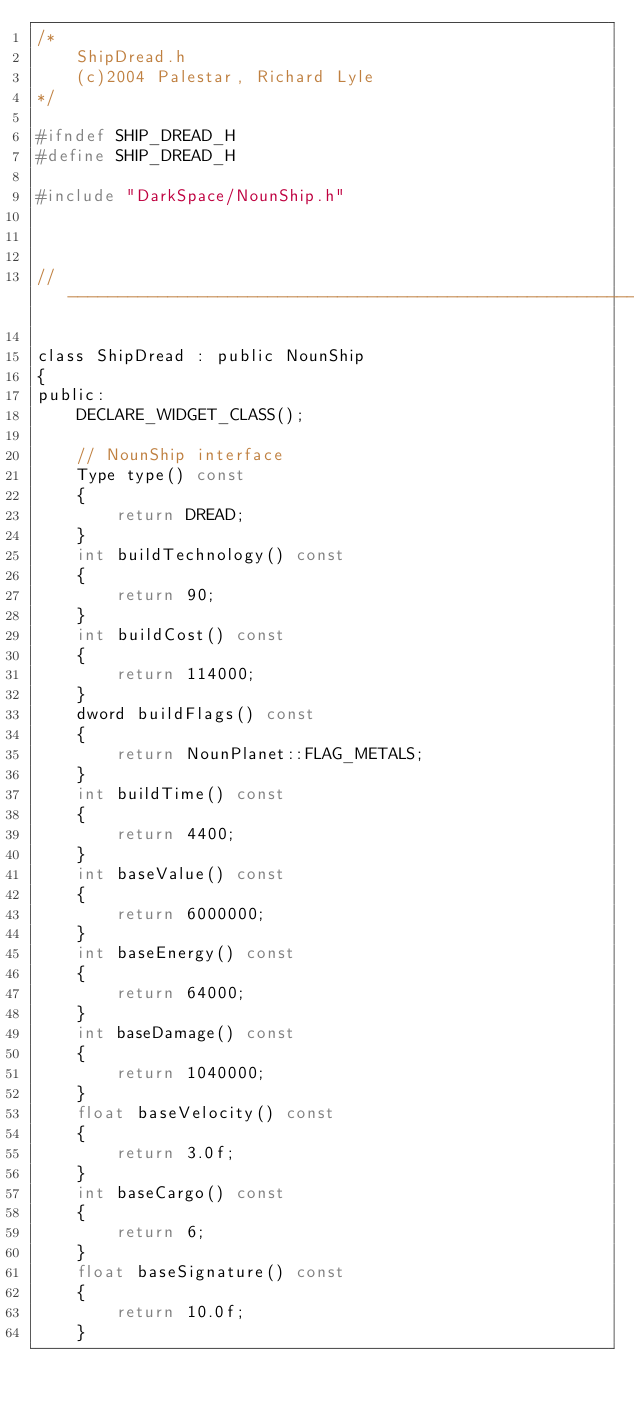Convert code to text. <code><loc_0><loc_0><loc_500><loc_500><_C_>/*
	ShipDread.h
	(c)2004 Palestar, Richard Lyle
*/

#ifndef SHIP_DREAD_H
#define SHIP_DREAD_H

#include "DarkSpace/NounShip.h"



//----------------------------------------------------------------------------

class ShipDread : public NounShip
{
public:
	DECLARE_WIDGET_CLASS();

	// NounShip interface
	Type type() const
	{
		return DREAD;
	}
	int buildTechnology() const
	{
		return 90;
	}
	int	buildCost() const
	{
		return 114000;
	}
	dword buildFlags() const
	{
		return NounPlanet::FLAG_METALS;
	}
	int	buildTime() const
	{
		return 4400;
	}
	int baseValue() const
	{
		return 6000000;
	}
	int baseEnergy() const
	{
		return 64000;
	}
	int baseDamage() const
	{
		return 1040000;
	}
	float baseVelocity() const
	{
		return 3.0f;
	}
	int baseCargo() const
	{
		return 6;
	}
	float baseSignature() const
	{
		return 10.0f;
	}</code> 